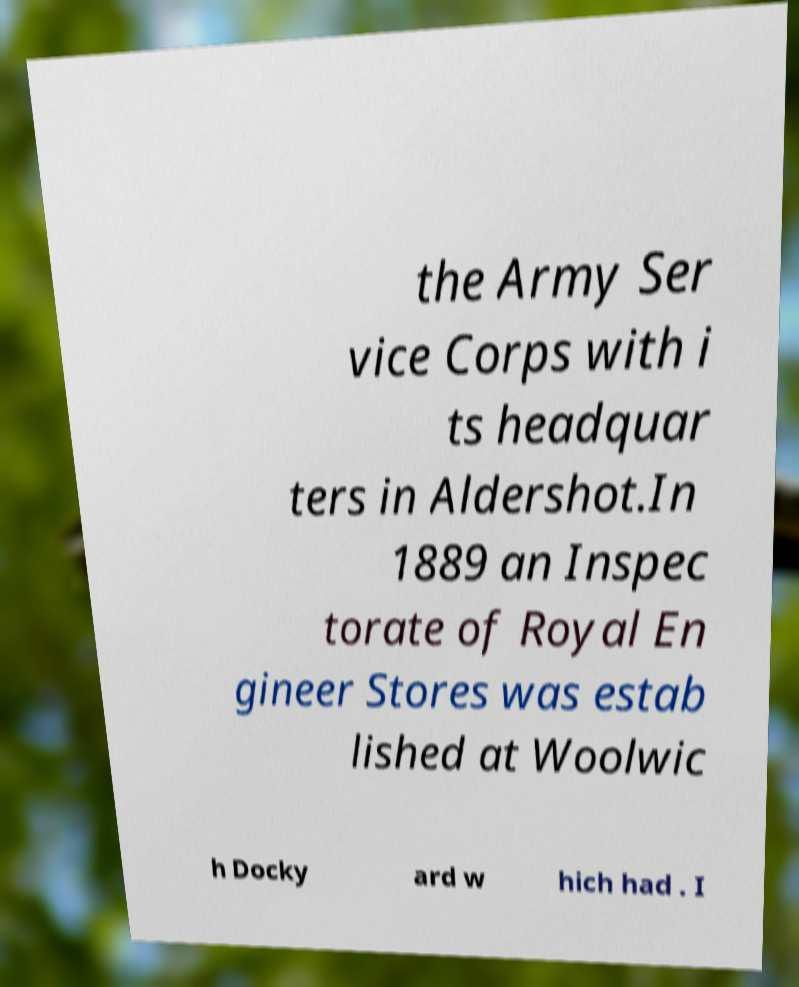Can you read and provide the text displayed in the image?This photo seems to have some interesting text. Can you extract and type it out for me? the Army Ser vice Corps with i ts headquar ters in Aldershot.In 1889 an Inspec torate of Royal En gineer Stores was estab lished at Woolwic h Docky ard w hich had . I 